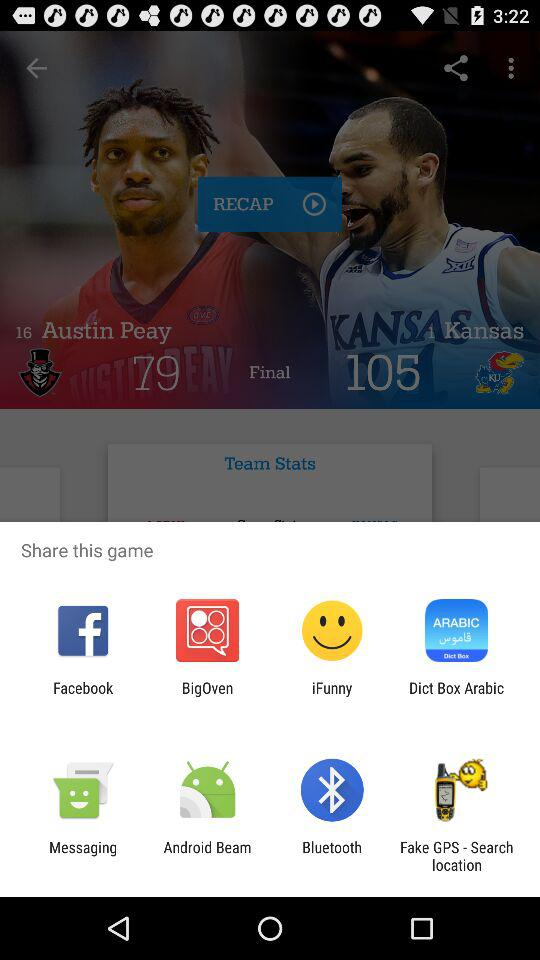Through which applications can we share the game? You can share the game through "Facebook", "BigOven", "iFunny", "Dict Box Arabic", "Messaging", "Android Beam", "Bluetooth" and "Fake GPS - Search location". 